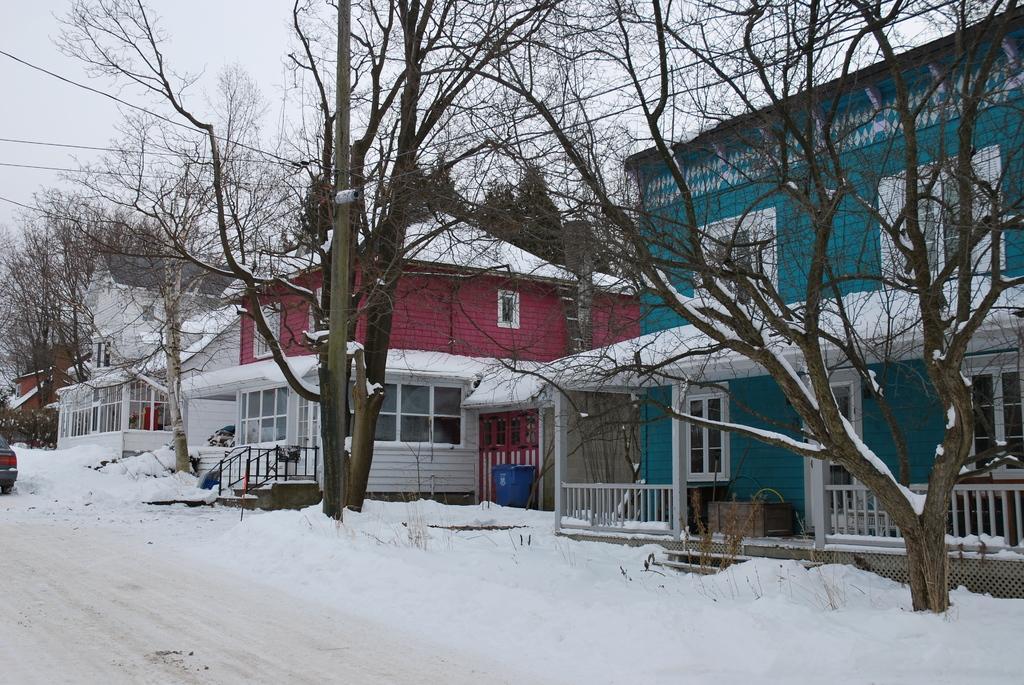Describe this image in one or two sentences. In the center of the image there are trees. There is a pole. In the background of the image there are houses. At the bottom of the image there is snow. 